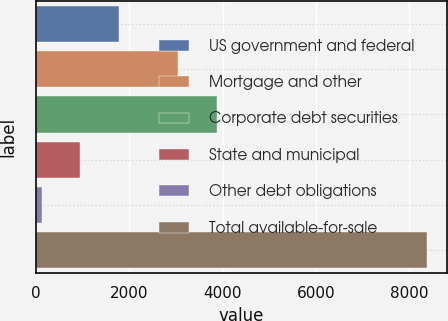Convert chart. <chart><loc_0><loc_0><loc_500><loc_500><bar_chart><fcel>US government and federal<fcel>Mortgage and other<fcel>Corporate debt securities<fcel>State and municipal<fcel>Other debt obligations<fcel>Total available-for-sale<nl><fcel>1768<fcel>3049<fcel>3877<fcel>940<fcel>112<fcel>8392<nl></chart> 